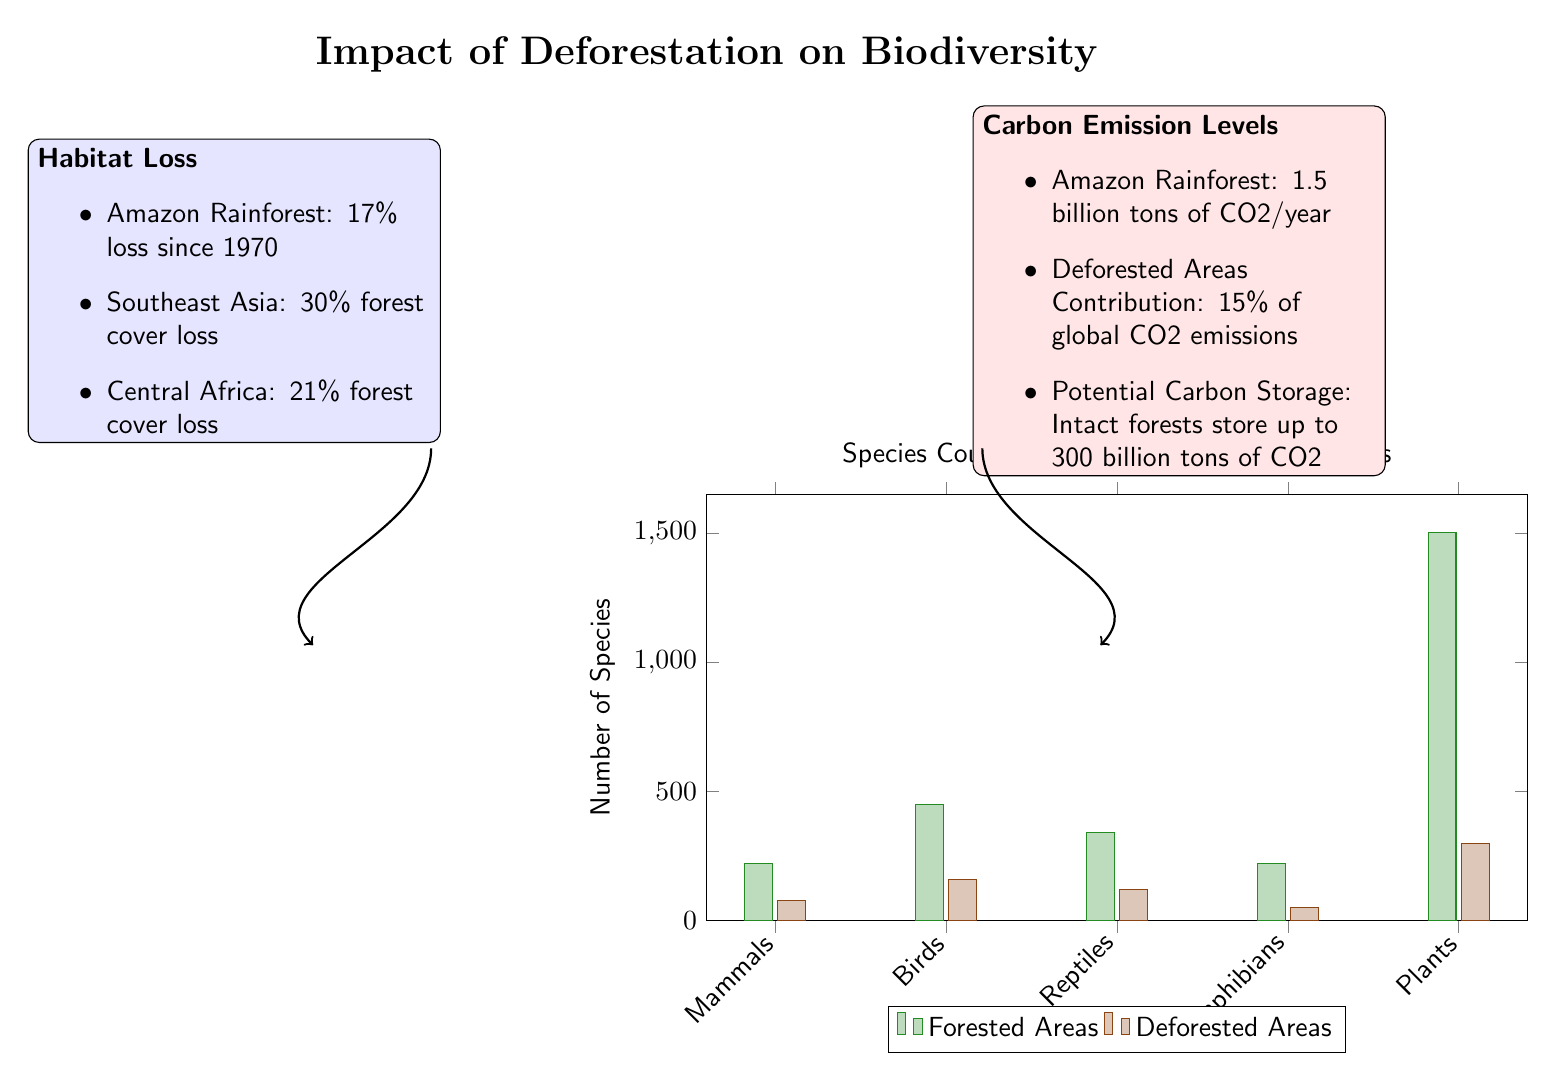What is the species count for Birds in forested areas? The bar for Birds in the forested areas shows a value of 450 in the chart, indicating the species count.
Answer: 450 What is the total number of species counted in deforested areas? By adding the species counts from deforested areas (80 for Mammals + 160 for Birds + 120 for Reptiles + 50 for Amphibians + 300 for Plants), the total equals 710 species.
Answer: 710 How many more Mammals are found in forested areas compared to deforested areas? The count for Mammals in forested areas is 220, and in deforested areas, it is 80. Subtracting gives 220 - 80 = 140 more Mammals.
Answer: 140 What percentage of carbon emissions comes from deforested areas? The infographic states that deforested areas contribute 15% of global CO2 emissions, which directly answers the question.
Answer: 15% Which species has the highest count in forested areas? The bar representing Plants in forested areas shows 1500 species, which is greater than the other categories.
Answer: Plants How does the habitat loss in Southeast Asia compare to that in Central Africa? Southeast Asia has a 30% forest cover loss, while Central Africa has a 21% loss. Therefore, Southeast Asia has a greater percentage of habitat loss.
Answer: 30% What is the carbon storage capacity of intact forests according to the infographic? The infographic indicates that intact forests can store up to 300 billion tons of CO2.
Answer: 300 billion tons What relationship can be inferred between habitat loss and species count in deforested areas? The species count in deforested areas is significantly lower compared to forested areas, suggesting that increased habitat loss likely leads to a decline in biodiversity.
Answer: Decline in biodiversity Which area has experienced a larger percentage of forest cover loss: Amazon Rainforest or Central Africa? The Amazon Rainforest has experienced a 17% loss since 1970, while Central Africa's loss is 21%, indicating that Central Africa has a larger percentage of forest cover loss.
Answer: Central Africa 